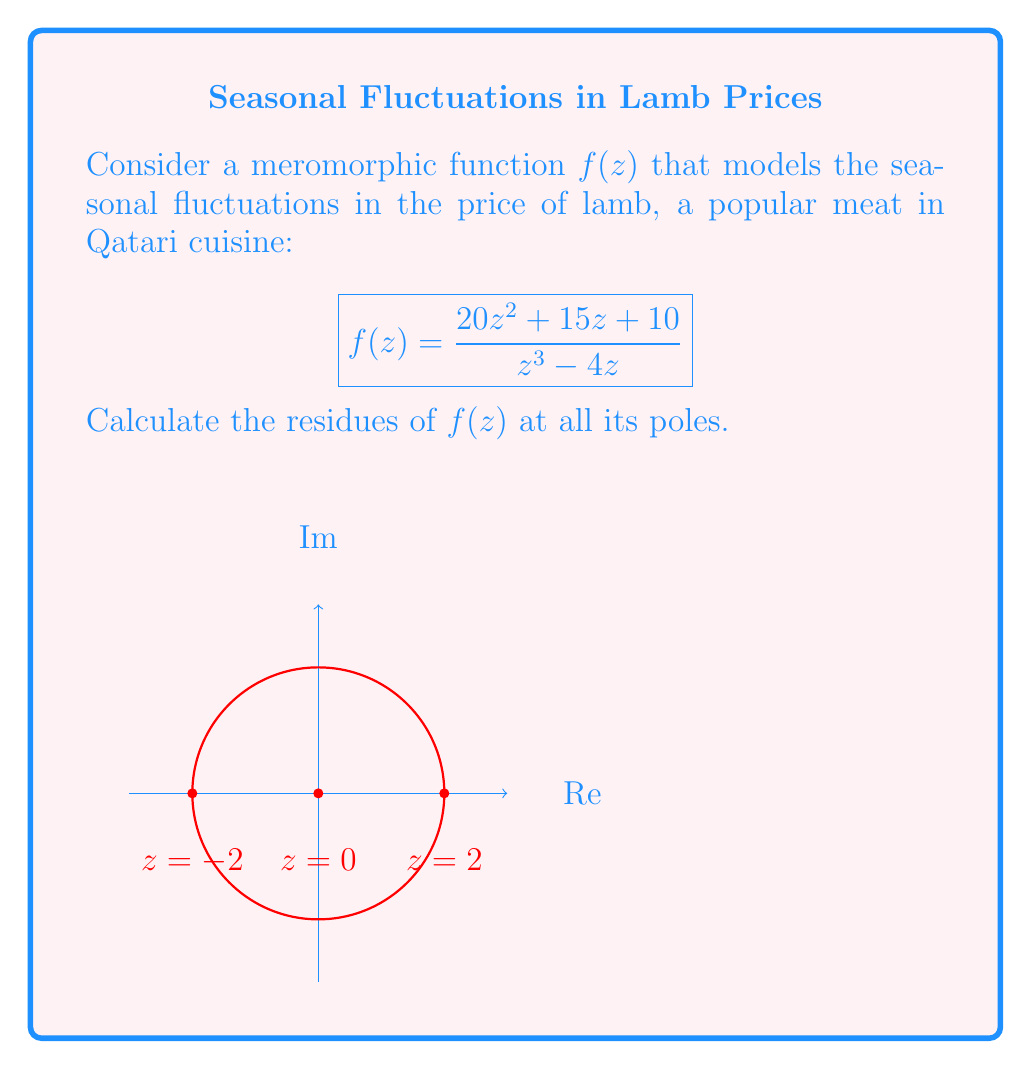Teach me how to tackle this problem. To calculate the residues, we need to identify the poles of $f(z)$ and determine their order:

1) The poles are at $z = 0, 2, -2$ (roots of the denominator).

2) For $z = 2$ and $z = -2$ (simple poles):
   Use the formula: $\text{Res}(f,a) = \lim_{z \to a} (z-a)f(z)$

   For $z = 2$:
   $$\text{Res}(f,2) = \lim_{z \to 2} (z-2)\frac{20z^2 + 15z + 10}{z^3 - 4z} = \frac{20(2)^2 + 15(2) + 10}{3(2)^2} = \frac{110}{12}$$

   For $z = -2$:
   $$\text{Res}(f,-2) = \lim_{z \to -2} (z+2)\frac{20z^2 + 15z + 10}{z^3 - 4z} = \frac{20(-2)^2 + 15(-2) + 10}{3(-2)^2} = \frac{50}{12}$$

3) For $z = 0$ (double pole):
   Use the formula: $\text{Res}(f,0) = \lim_{z \to 0} \frac{d}{dz}[z^2f(z)]$

   $$\begin{align*}
   \text{Res}(f,0) &= \lim_{z \to 0} \frac{d}{dz}\left[z^2 \cdot \frac{20z^2 + 15z + 10}{z^3 - 4z}\right] \\
   &= \lim_{z \to 0} \frac{d}{dz}\left[\frac{20z^4 + 15z^3 + 10z^2}{z^4 - 4z^2}\right] \\
   &= \lim_{z \to 0} \frac{d}{dz}\left[\frac{20z^2 + 15z + 10}{z^2 - 4}\right] \\
   &= \lim_{z \to 0} \frac{(40z + 15)(z^2 - 4) - (20z^2 + 15z + 10)(2z)}{(z^2 - 4)^2} \\
   &= \frac{-60 - 80}{16} = -\frac{35}{4}
   \end{align*}$$
Answer: $\text{Res}(f,2) = \frac{110}{12}, \text{Res}(f,-2) = \frac{50}{12}, \text{Res}(f,0) = -\frac{35}{4}$ 